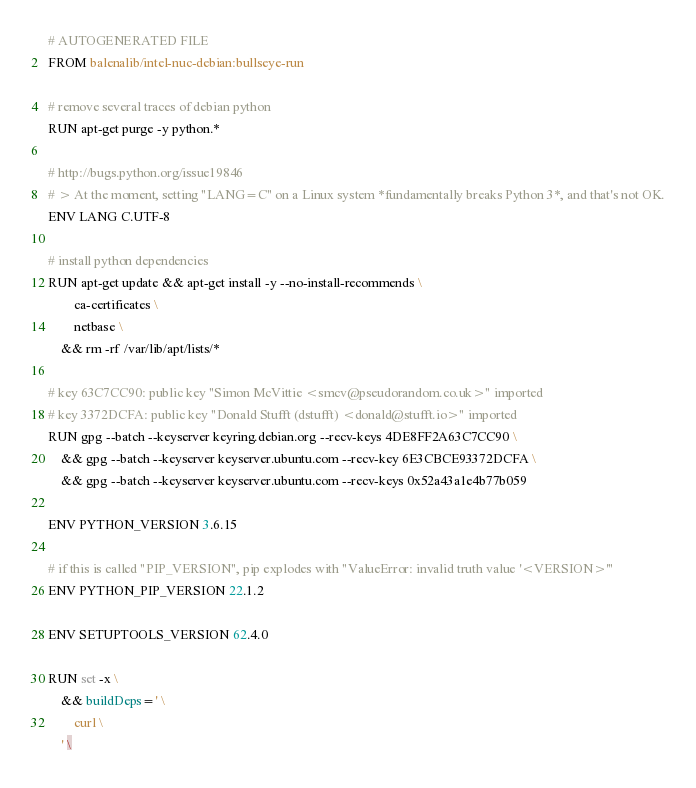<code> <loc_0><loc_0><loc_500><loc_500><_Dockerfile_># AUTOGENERATED FILE
FROM balenalib/intel-nuc-debian:bullseye-run

# remove several traces of debian python
RUN apt-get purge -y python.*

# http://bugs.python.org/issue19846
# > At the moment, setting "LANG=C" on a Linux system *fundamentally breaks Python 3*, and that's not OK.
ENV LANG C.UTF-8

# install python dependencies
RUN apt-get update && apt-get install -y --no-install-recommends \
		ca-certificates \
		netbase \
	&& rm -rf /var/lib/apt/lists/*

# key 63C7CC90: public key "Simon McVittie <smcv@pseudorandom.co.uk>" imported
# key 3372DCFA: public key "Donald Stufft (dstufft) <donald@stufft.io>" imported
RUN gpg --batch --keyserver keyring.debian.org --recv-keys 4DE8FF2A63C7CC90 \
	&& gpg --batch --keyserver keyserver.ubuntu.com --recv-key 6E3CBCE93372DCFA \
	&& gpg --batch --keyserver keyserver.ubuntu.com --recv-keys 0x52a43a1e4b77b059

ENV PYTHON_VERSION 3.6.15

# if this is called "PIP_VERSION", pip explodes with "ValueError: invalid truth value '<VERSION>'"
ENV PYTHON_PIP_VERSION 22.1.2

ENV SETUPTOOLS_VERSION 62.4.0

RUN set -x \
	&& buildDeps=' \
		curl \
	' \</code> 